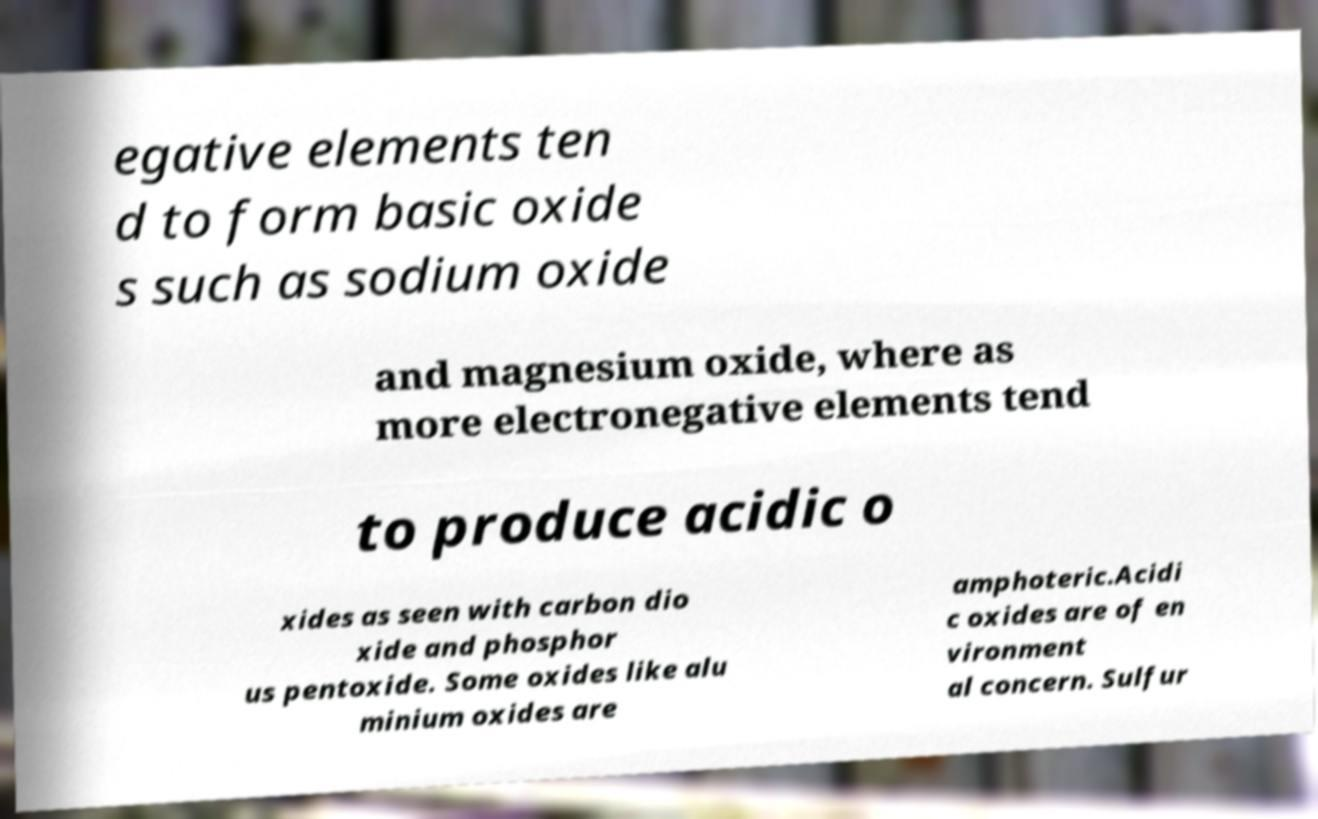Please read and relay the text visible in this image. What does it say? egative elements ten d to form basic oxide s such as sodium oxide and magnesium oxide, where as more electronegative elements tend to produce acidic o xides as seen with carbon dio xide and phosphor us pentoxide. Some oxides like alu minium oxides are amphoteric.Acidi c oxides are of en vironment al concern. Sulfur 